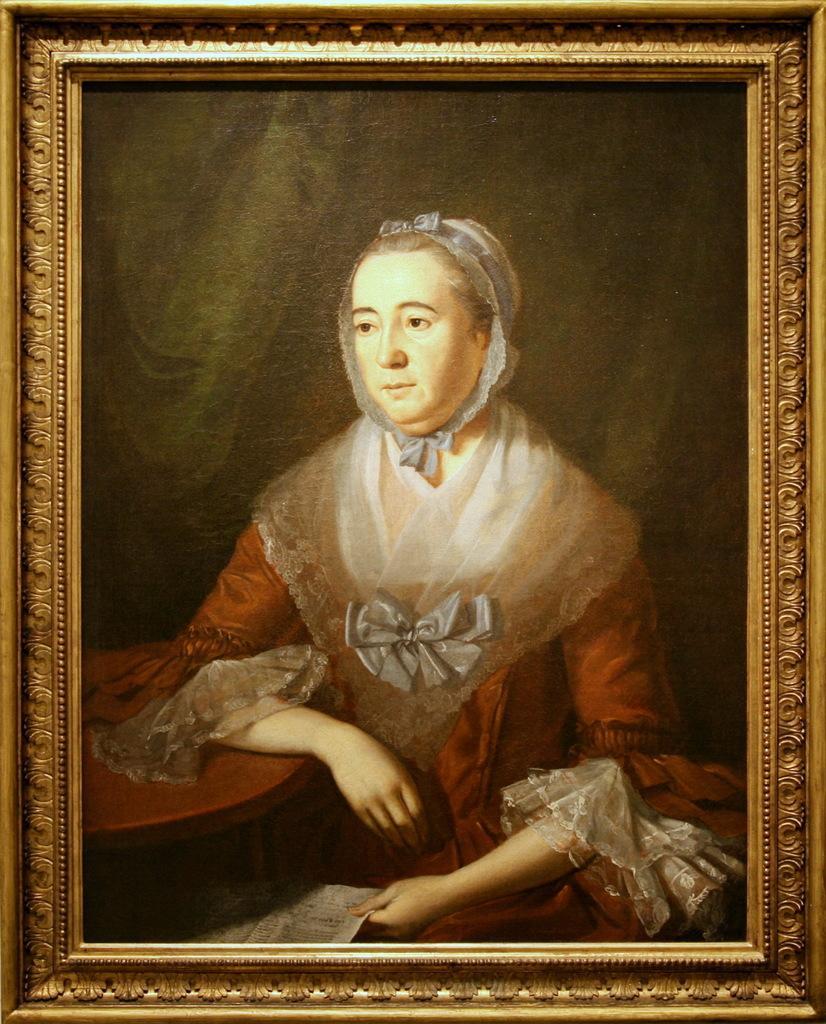Could you give a brief overview of what you see in this image? In this image we can see a frame. In frame one lady painting is present. She is holding paper in her hand and she is wearing red and white color dress. 